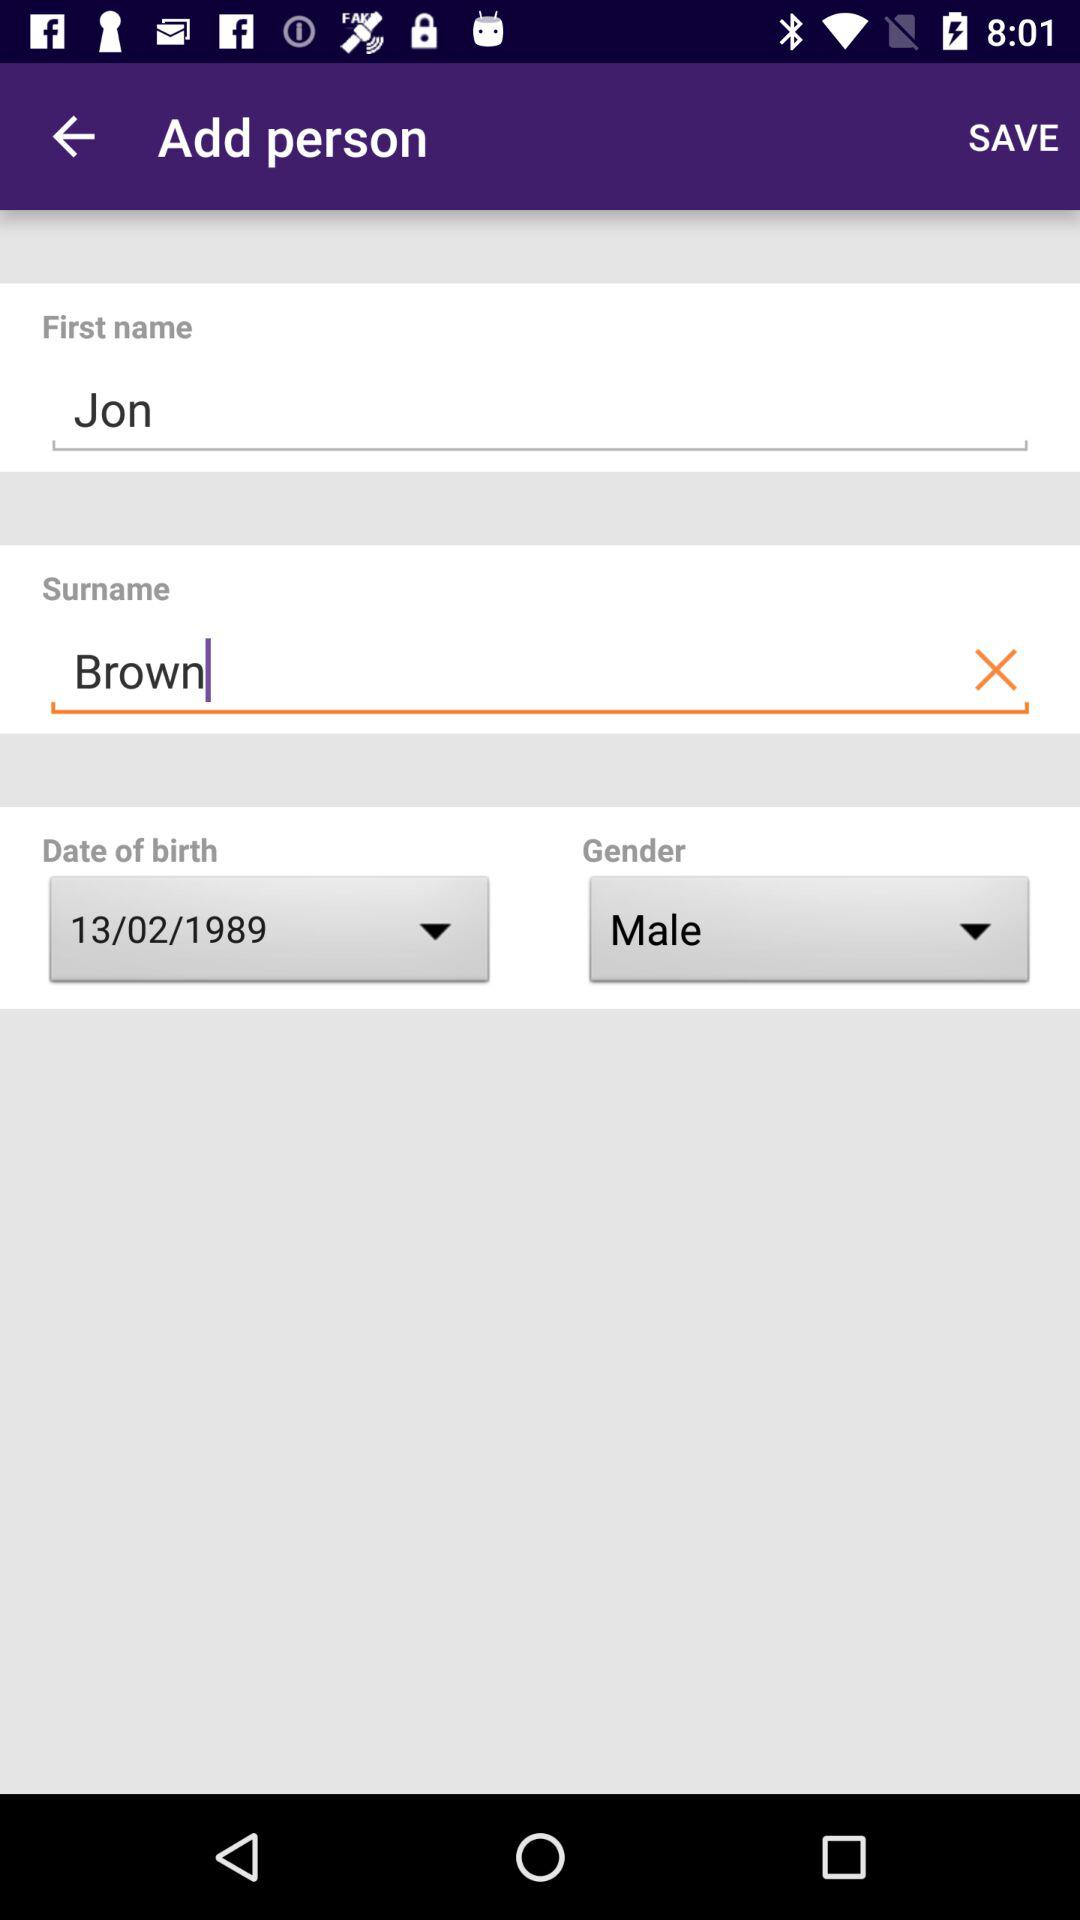What is the surname? The surname is Brown. 